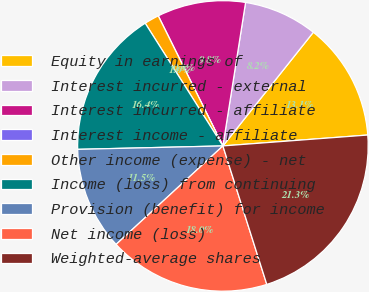Convert chart. <chart><loc_0><loc_0><loc_500><loc_500><pie_chart><fcel>Equity in earnings of<fcel>Interest incurred - external<fcel>Interest incurred - affiliate<fcel>Interest income - affiliate<fcel>Other income (expense) - net<fcel>Income (loss) from continuing<fcel>Provision (benefit) for income<fcel>Net income (loss)<fcel>Weighted-average shares<nl><fcel>13.11%<fcel>8.2%<fcel>9.84%<fcel>0.0%<fcel>1.64%<fcel>16.39%<fcel>11.48%<fcel>18.03%<fcel>21.31%<nl></chart> 